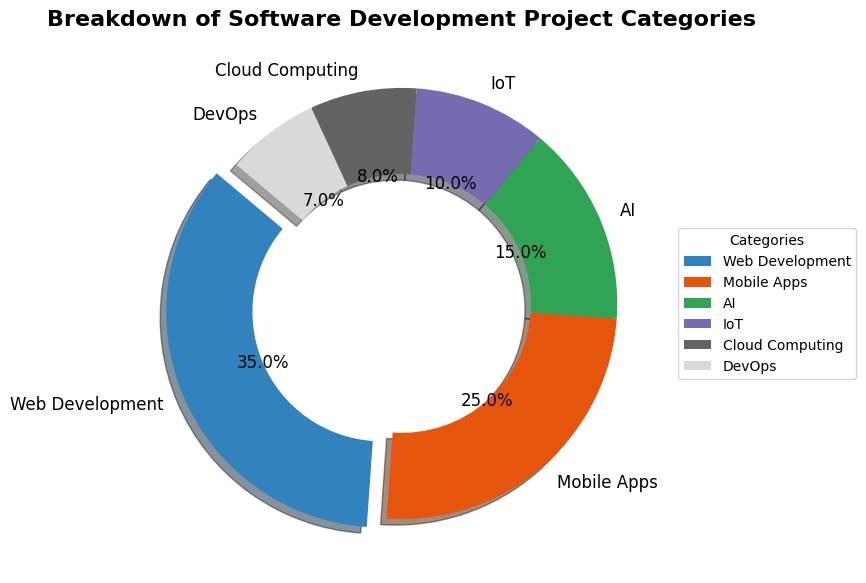Which category has the highest percentage? The category with the highest percentage can be identified by looking at the largest wedge on the pie chart. There is also an explode effect on the largest wedge, making it stand out from the rest. The category labeled "Web Development" has the highest percentage, which is indicated to be 35%.
Answer: Web Development Which two categories combined cover exactly 50% of project categories? To find which two categories combined cover 50%, look at the percentages of each category and find two that sum up to 50%. The "Mobile Apps" category covers 25%, and the "Web Development" category covers 35%. Summing these two gives 25% + 35% = 60%, which is not 50%. Now, consider "AI" with 15% and "Web Development" with 35%. Their sum is 15% + 35% = 50%.
Answer: AI and Web Development Which category has the smallest representation in the pie chart? The smallest representation would be the category with the smallest percentage, which can be identified by finding the smallest wedge in the pie chart. The label indicates "DevOps" with 7%.
Answer: DevOps What is the difference in percentage between the largest and the smallest category? To find the difference in percentage, subtract the smallest percentage from the largest. The largest is "Web Development" with 35%, and the smallest is "DevOps" with 7%. So, 35% - 7% = 28%.
Answer: 28% How many categories have a percentage greater than or equal to 15%? Count the number of wedges with percentages 15% or higher. From the categories: Web Development (35%), Mobile Apps (25%), and AI (15%) are each equal to or higher than 15%. That's 3 categories in total.
Answer: 3 Is the representation of "Cloud Computing" more or less than "AI" in terms of percentage? Compare the percentages of "Cloud Computing" and "AI". "Cloud Computing" has 8%, while "AI" has 15%. Since 8% is less than 15%, "Cloud Computing" is less than "AI".
Answer: Less What percentage of the pie chart is covered by categories other than "Web Development" and "Mobile Apps"? First, find the sum of "Web Development" and "Mobile Apps". This is 35% + 25% = 60%. Subtract this from 100% to find the percentage of the remaining categories: 100% - 60% = 40%.
Answer: 40% Does the total percentage of AI and IoT projects exceed that of Mobile Apps? Calculate the combined percentage of AI and IoT: 15% (AI) + 10% (IoT) = 25%. The Mobile Apps category is also 25%. Therefore, AI and IoT combined do not exceed Mobile Apps; they are equal.
Answer: No What is the total percentage of the categories with less than 10% representation? Identify the categories with less than 10%: "DevOps" (7%) and "Cloud Computing" (8%). Sum these percentages: 7% + 8% = 15%.
Answer: 15% Which category is represented in blue color? In a pie chart, specific colors are often used to represent different categories. Since the figure style wasn't explicitly defined, observe the color key in the legend to find the exact category represented by blue, which is "Mobile Apps" in the pie chart being described.
Answer: Mobile Apps 